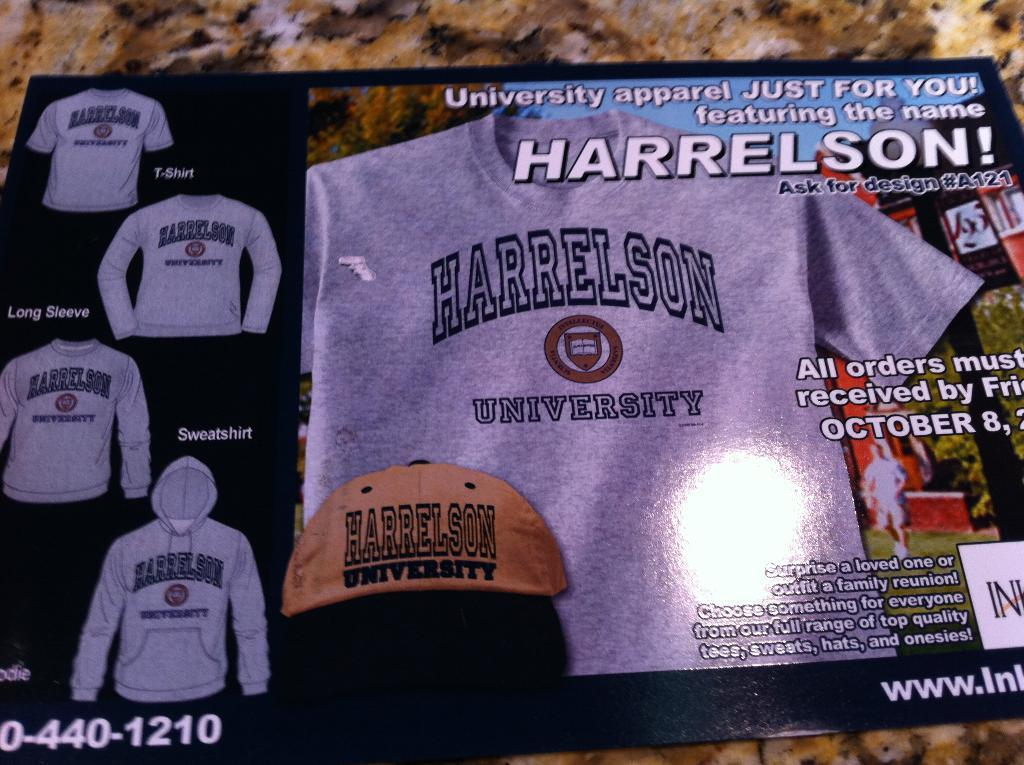<image>
Give a short and clear explanation of the subsequent image. An ad for Harrelson University apparel shows hats and sweatshirts. 